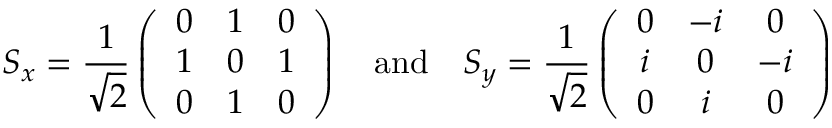<formula> <loc_0><loc_0><loc_500><loc_500>S _ { x } = \frac { 1 } { \sqrt { 2 } } \left ( \begin{array} { c c c } { 0 } & { 1 } & { 0 } \\ { 1 } & { 0 } & { 1 } \\ { 0 } & { 1 } & { 0 } \end{array} \right ) \quad a n d \quad S _ { y } = \frac { 1 } { \sqrt { 2 } } \left ( \begin{array} { c c c } { 0 } & { - i } & { 0 } \\ { i } & { 0 } & { - i } \\ { 0 } & { i } & { 0 } \end{array} \right )</formula> 